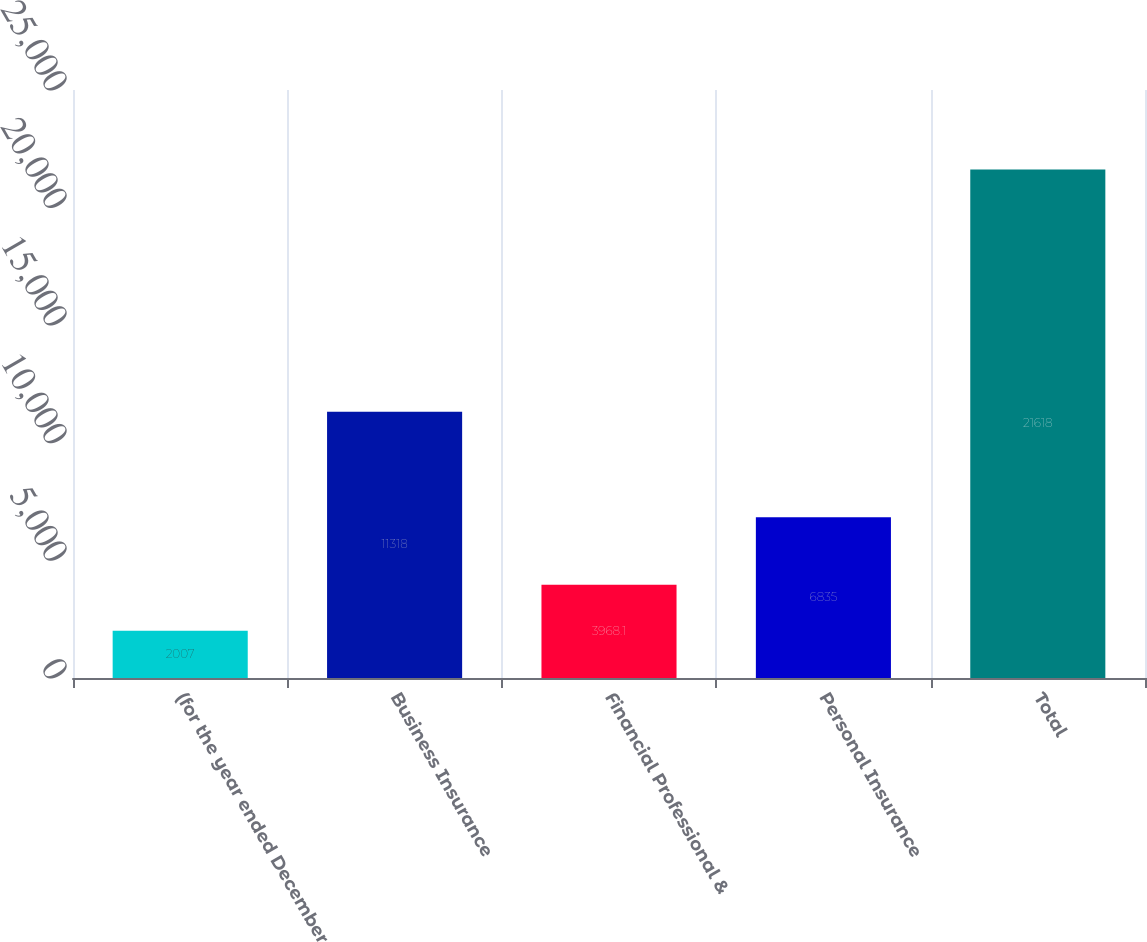<chart> <loc_0><loc_0><loc_500><loc_500><bar_chart><fcel>(for the year ended December<fcel>Business Insurance<fcel>Financial Professional &<fcel>Personal Insurance<fcel>Total<nl><fcel>2007<fcel>11318<fcel>3968.1<fcel>6835<fcel>21618<nl></chart> 